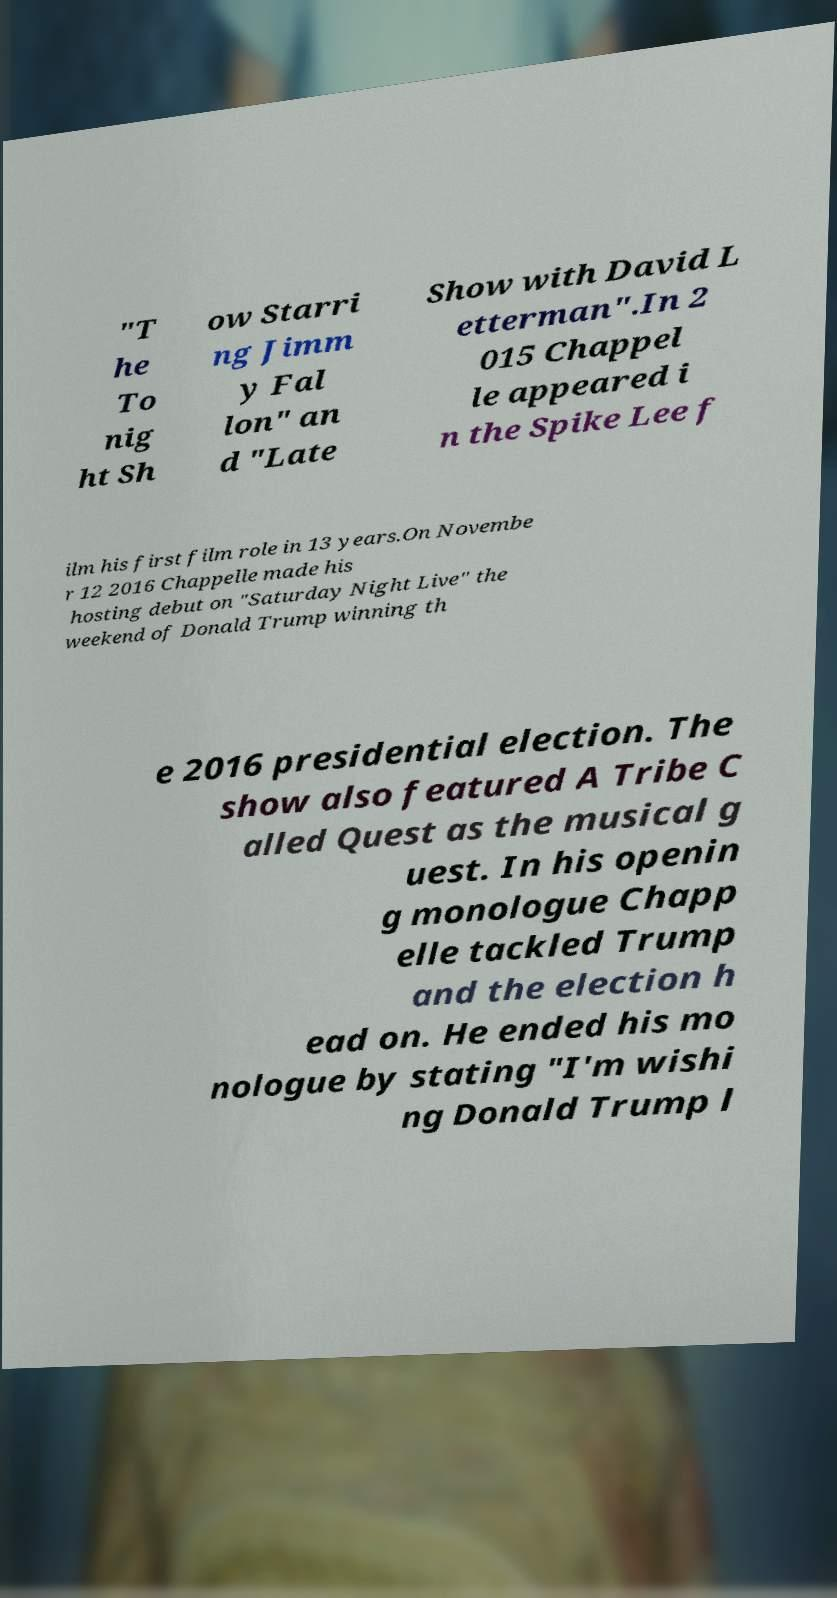Could you extract and type out the text from this image? "T he To nig ht Sh ow Starri ng Jimm y Fal lon" an d "Late Show with David L etterman".In 2 015 Chappel le appeared i n the Spike Lee f ilm his first film role in 13 years.On Novembe r 12 2016 Chappelle made his hosting debut on "Saturday Night Live" the weekend of Donald Trump winning th e 2016 presidential election. The show also featured A Tribe C alled Quest as the musical g uest. In his openin g monologue Chapp elle tackled Trump and the election h ead on. He ended his mo nologue by stating "I'm wishi ng Donald Trump l 